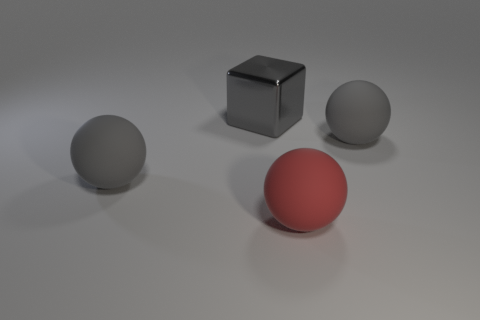Subtract all large gray matte spheres. How many spheres are left? 1 Subtract all green cylinders. How many gray spheres are left? 2 Add 3 small brown metallic cylinders. How many objects exist? 7 Subtract all blocks. How many objects are left? 3 Subtract all large red matte balls. Subtract all matte balls. How many objects are left? 0 Add 1 large rubber balls. How many large rubber balls are left? 4 Add 3 large gray rubber balls. How many large gray rubber balls exist? 5 Subtract 0 yellow cylinders. How many objects are left? 4 